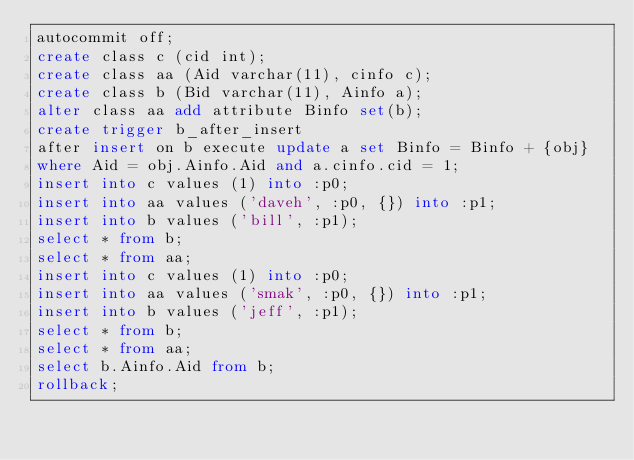Convert code to text. <code><loc_0><loc_0><loc_500><loc_500><_SQL_>autocommit off;
create class c (cid int);
create class aa (Aid varchar(11), cinfo c);
create class b (Bid varchar(11), Ainfo a);
alter class aa add attribute Binfo set(b);
create trigger b_after_insert
after insert on b execute update a set Binfo = Binfo + {obj}
where Aid = obj.Ainfo.Aid and a.cinfo.cid = 1;
insert into c values (1) into :p0;
insert into aa values ('daveh', :p0, {}) into :p1;
insert into b values ('bill', :p1);
select * from b;
select * from aa;
insert into c values (1) into :p0;
insert into aa values ('smak', :p0, {}) into :p1;
insert into b values ('jeff', :p1);
select * from b;
select * from aa;
select b.Ainfo.Aid from b;
rollback;
</code> 